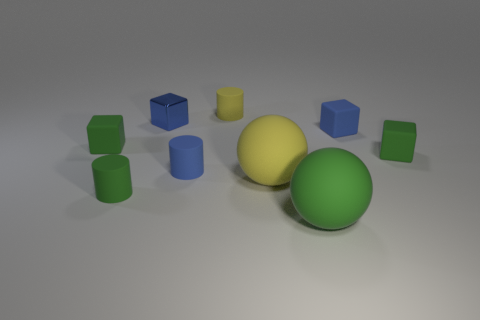Subtract all cyan cylinders. Subtract all yellow blocks. How many cylinders are left? 3 Subtract all yellow balls. How many cyan cubes are left? 0 Add 8 small objects. How many greens exist? 0 Subtract all tiny green blocks. Subtract all green rubber cubes. How many objects are left? 5 Add 4 balls. How many balls are left? 6 Add 2 green objects. How many green objects exist? 6 Add 1 small blue metallic things. How many objects exist? 10 Subtract all yellow cylinders. How many cylinders are left? 2 Subtract all shiny cubes. How many cubes are left? 3 Subtract 0 brown spheres. How many objects are left? 9 